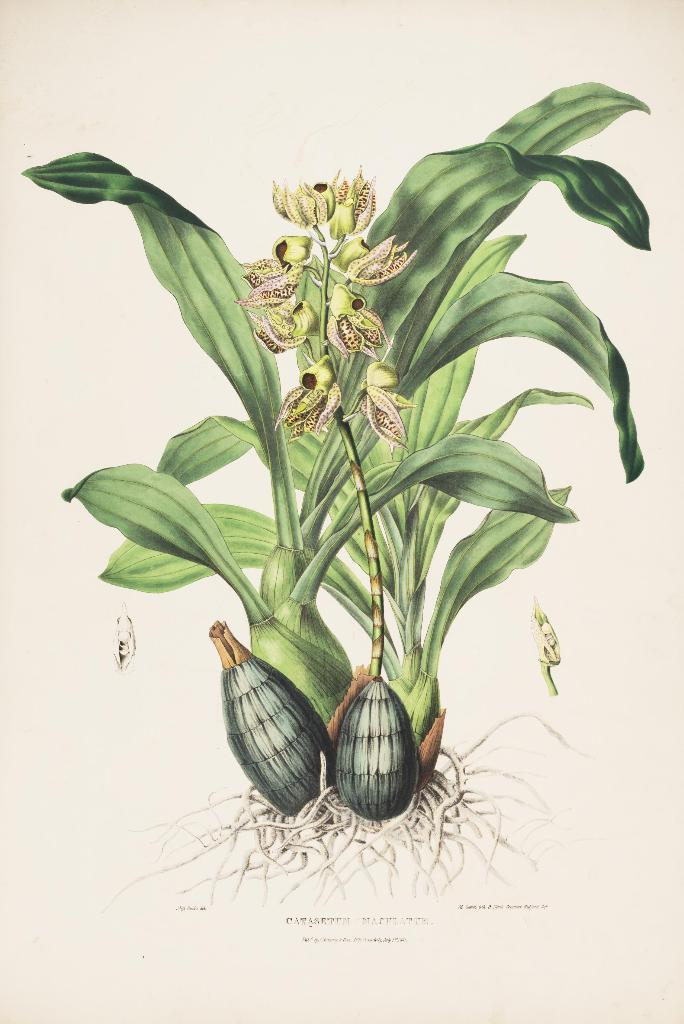What is depicted on the paper in the image? There is a picture of plants printed on paper. What else can be seen on the paper besides the picture of plants? There is text visible in the image. What type of plants are shown in the image? There are flowers in the image. How many spots can be seen on the flowers in the image? There are no spots visible on the flowers in the image. 